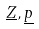<formula> <loc_0><loc_0><loc_500><loc_500>\underline { Z } , \underline { p }</formula> 